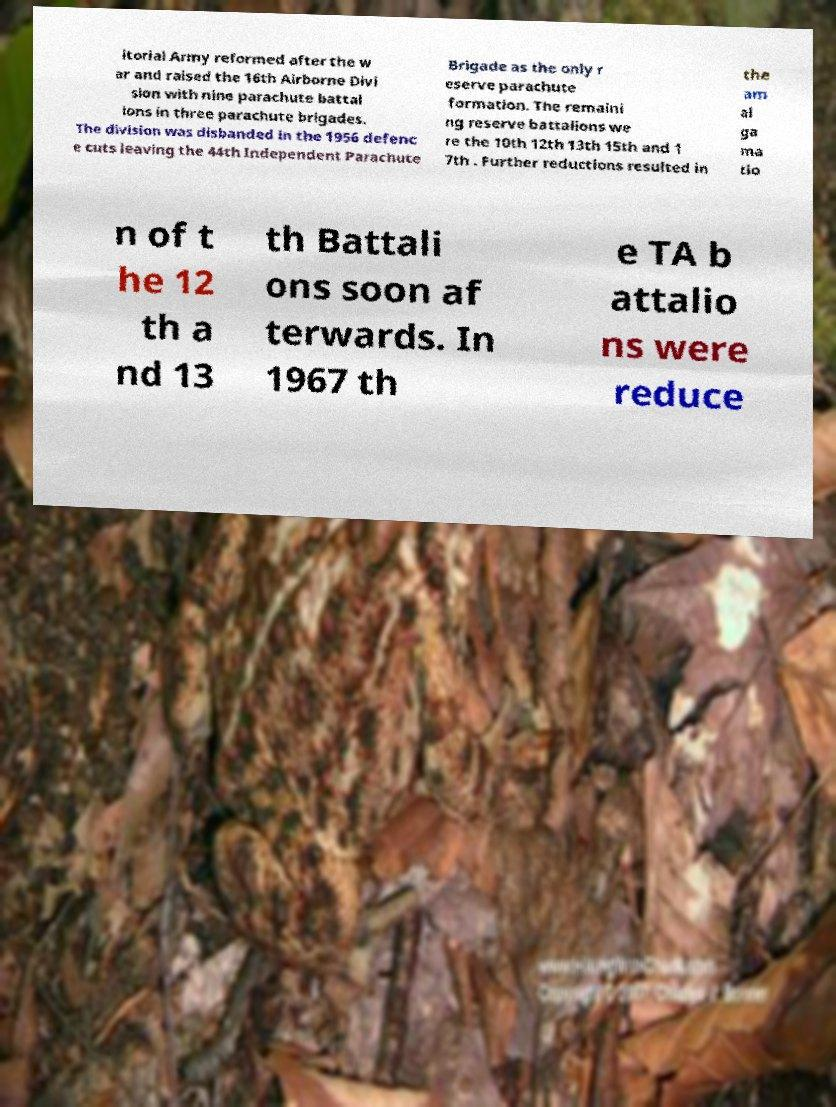I need the written content from this picture converted into text. Can you do that? itorial Army reformed after the w ar and raised the 16th Airborne Divi sion with nine parachute battal ions in three parachute brigades. The division was disbanded in the 1956 defenc e cuts leaving the 44th Independent Parachute Brigade as the only r eserve parachute formation. The remaini ng reserve battalions we re the 10th 12th 13th 15th and 1 7th . Further reductions resulted in the am al ga ma tio n of t he 12 th a nd 13 th Battali ons soon af terwards. In 1967 th e TA b attalio ns were reduce 